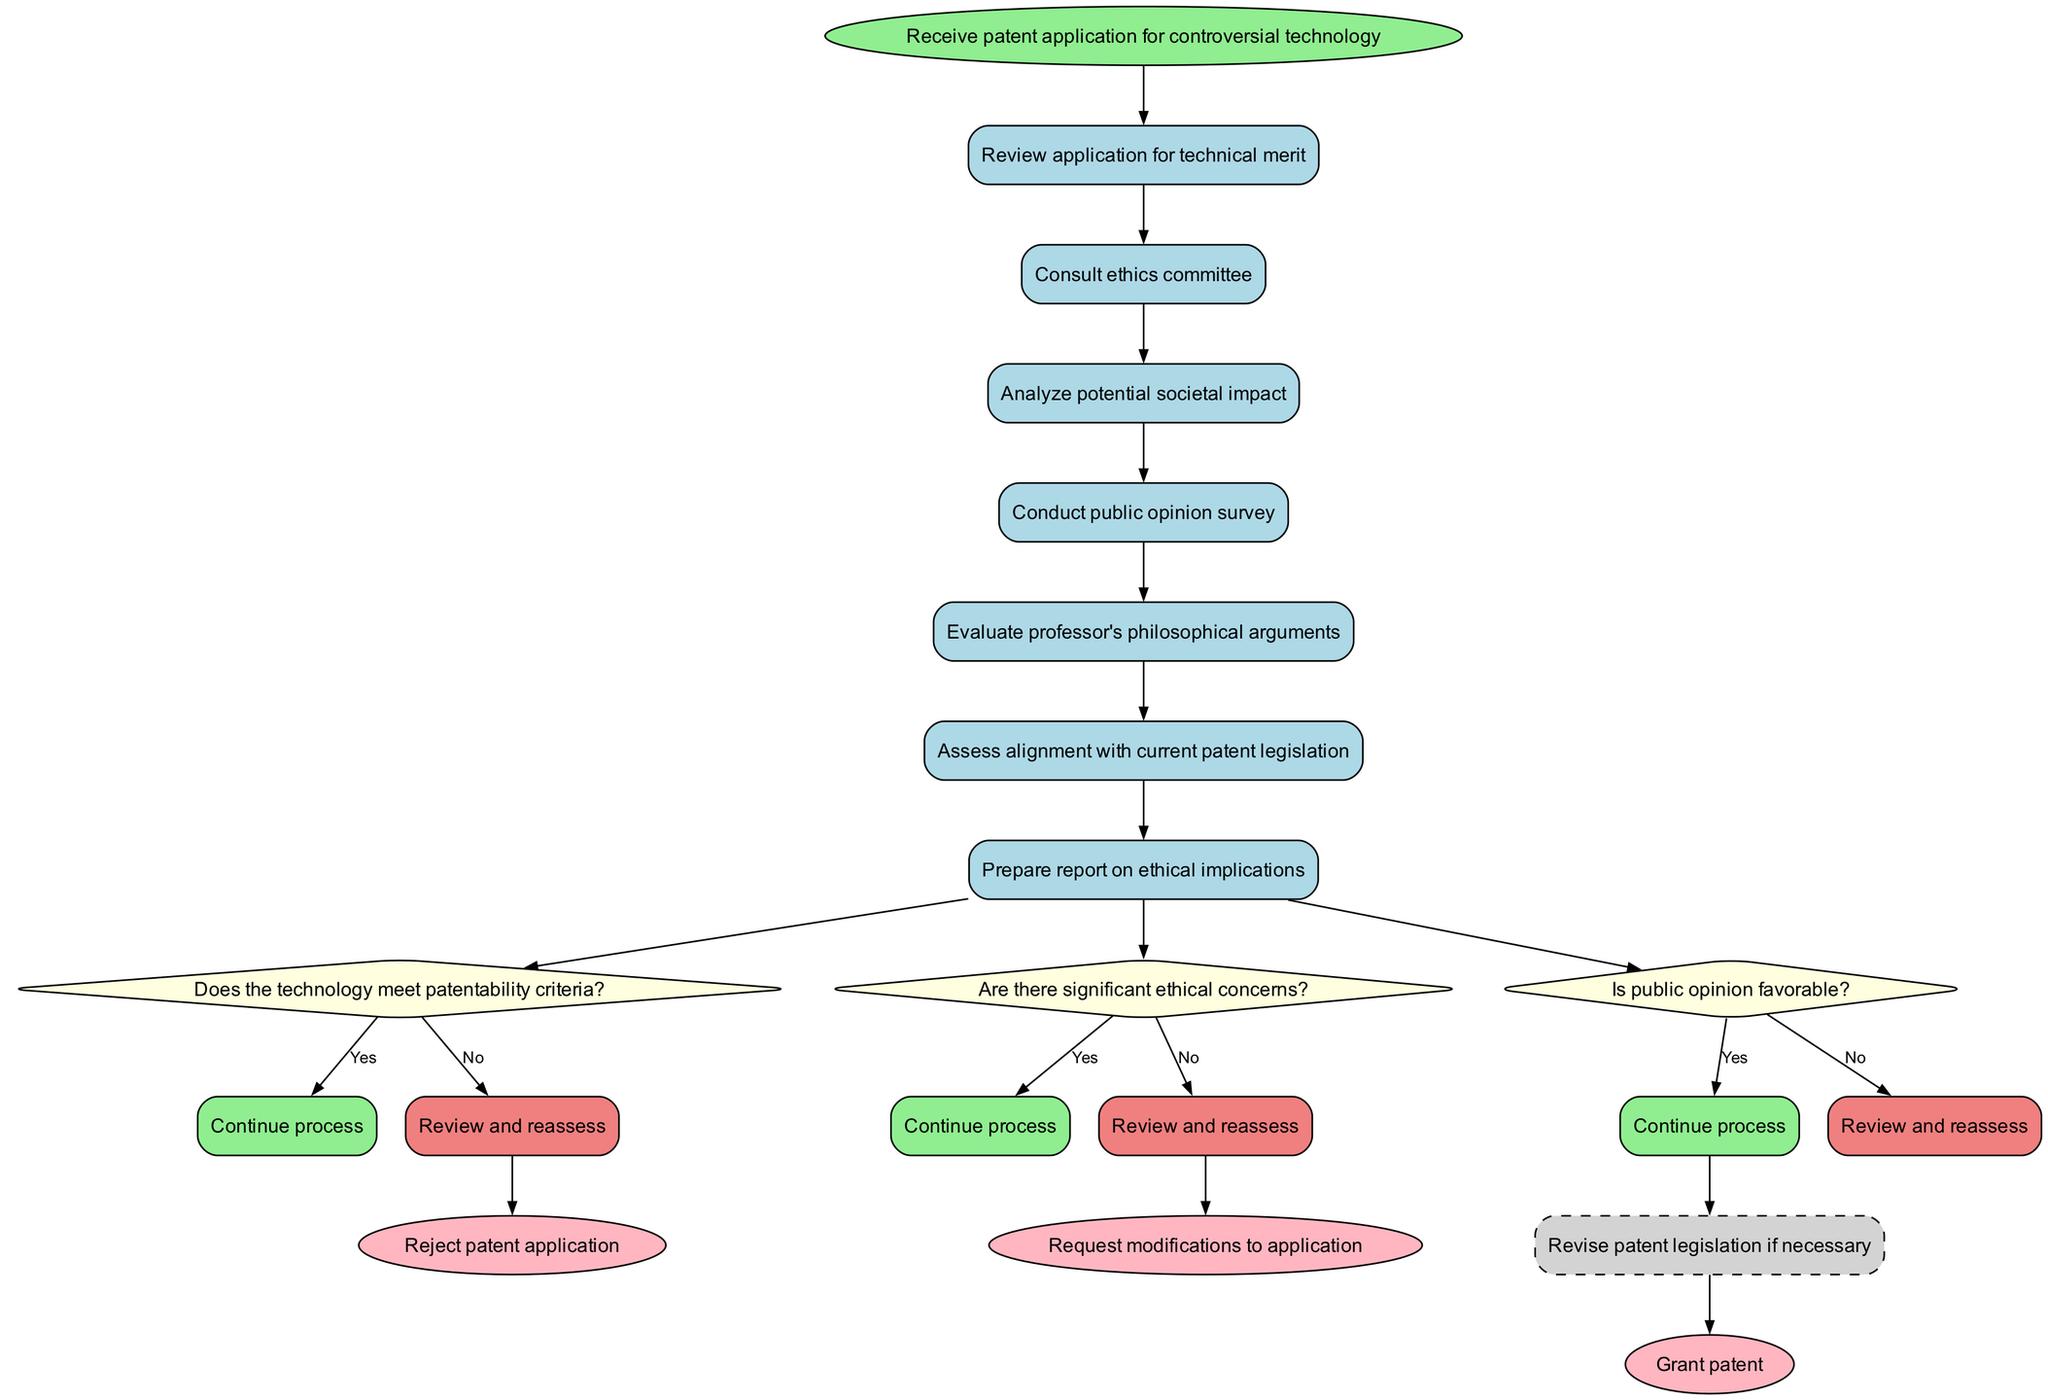What is the first activity in the patent application process? The diagram shows that the first activity listed is "Review application for technical merit." This is derived from the order of activities displayed, where the first activity follows the start node.
Answer: Review application for technical merit How many decisions are presented in the diagram? By counting the decision nodes marked as diamonds in the diagram, we see there are three decision nodes: one for patentability criteria, one for ethical concerns, and one for public opinion.
Answer: 3 What are the options for the second decision regarding ethics? The second decision listed in the diagram asks if there are significant ethical concerns and provides the options "Yes" and "No." These options are part of the decision-making process regarding the ethical implications of the technology.
Answer: Yes, No If public opinion is not favorable, what action is indicated by the diagram? According to the flow from the decision node about public opinion, if the answer is "No" (indicating that public opinion is not favorable), the diagram shows that the flow leads to "Review and reassess." This indicates a need for further consideration regarding the application.
Answer: Review and reassess What subprocess is mentioned for revising legislation? The subprocess labeled in the diagram is "Revise patent legislation if necessary." This indicates a step that may occur based on findings from the main decision-making process.
Answer: Revise patent legislation if necessary What happens if the technology meets patentability criteria? The diagram specifies that if the technology meets patentability criteria ("Yes" response), it continues the process, which implies progression to the next steps outlined in the subsequent nodes.
Answer: Continue process Which activity assesses alignment with current patent legislation? The activity that specifically assesses alignment with current patent legislation is labeled as "Assess alignment with current patent legislation." This is one of the activities that follows after reviewing the application and consulting the ethics committee.
Answer: Assess alignment with current patent legislation What is the outcome if the patent application is rejected? The diagram indicates that if the patent application is rejected, the outcome is documented as "Reject patent application." This provides a clear endpoint for that particular branch of the decision-making process.
Answer: Reject patent application 